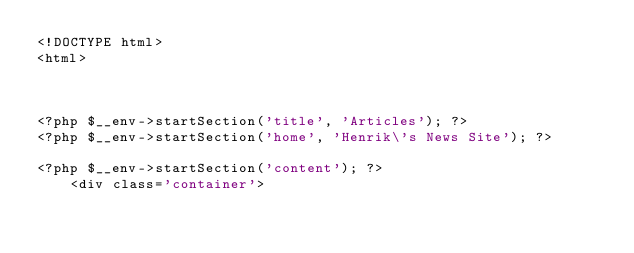<code> <loc_0><loc_0><loc_500><loc_500><_PHP_><!DOCTYPE html>
<html>



<?php $__env->startSection('title', 'Articles'); ?>
<?php $__env->startSection('home', 'Henrik\'s News Site'); ?>

<?php $__env->startSection('content'); ?>
    <div class='container'></code> 